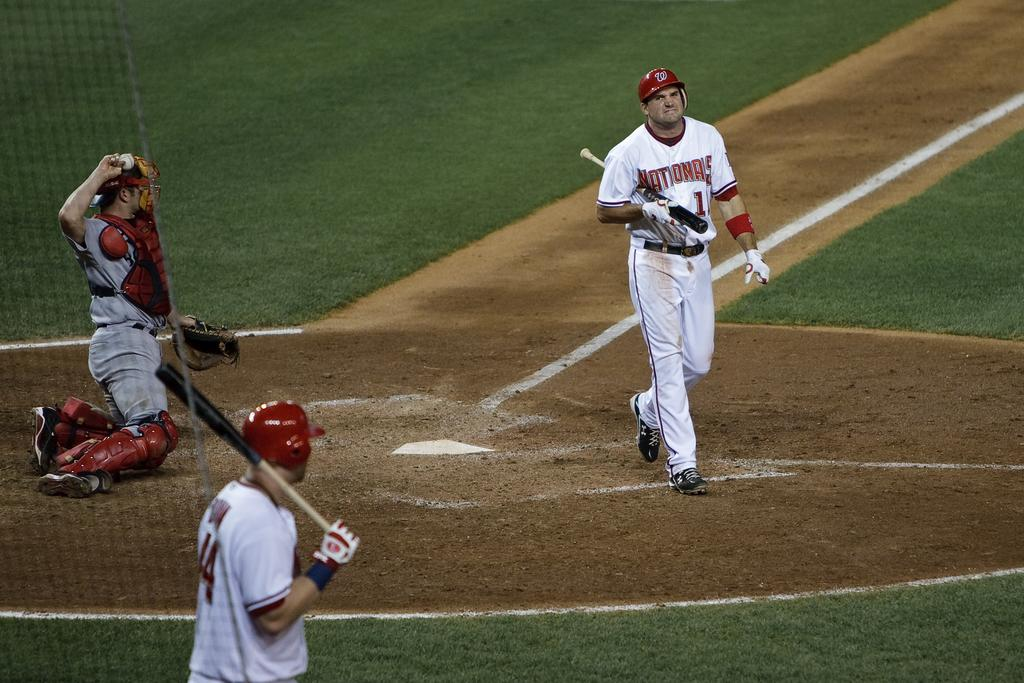<image>
Relay a brief, clear account of the picture shown. Number 1 for the Nationals walks away from the plate with a disappointed look on his face. 